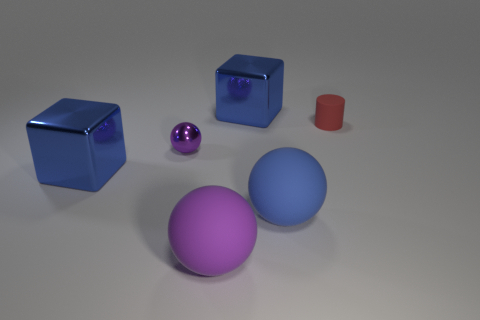There is a blue cube that is on the left side of the tiny ball to the left of the red matte cylinder; are there any tiny spheres that are left of it?
Offer a very short reply. No. There is a thing that is the same size as the metal sphere; what shape is it?
Offer a very short reply. Cylinder. Is there a cube that has the same color as the small cylinder?
Your response must be concise. No. Is the shape of the red thing the same as the small purple metal thing?
Your answer should be compact. No. How many small things are blocks or blue matte blocks?
Give a very brief answer. 0. There is a cylinder that is the same material as the blue ball; what color is it?
Your answer should be very brief. Red. What number of large objects have the same material as the small purple sphere?
Your answer should be very brief. 2. There is a blue cube that is behind the small red cylinder; does it have the same size as the purple rubber ball that is in front of the tiny purple ball?
Your answer should be compact. Yes. There is a sphere behind the large blue metal block that is to the left of the purple metal ball; what is its material?
Keep it short and to the point. Metal. Is the number of big things in front of the purple matte object less than the number of big blue things that are in front of the tiny purple object?
Your answer should be compact. Yes. 